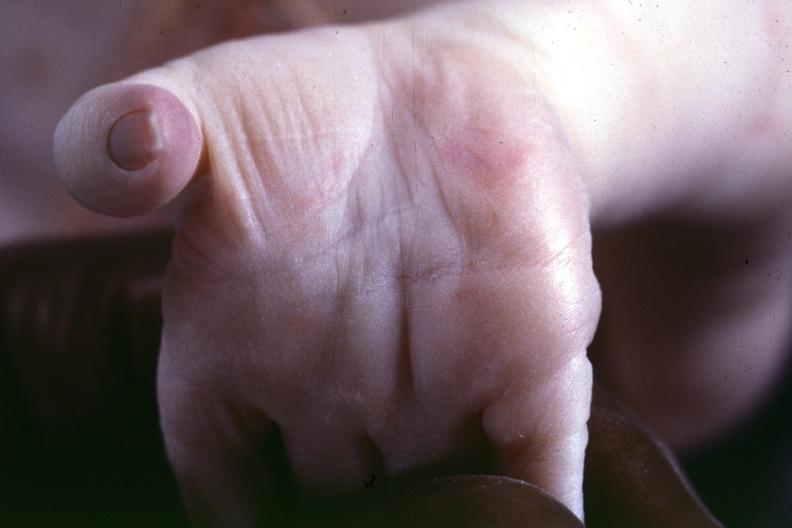s malignant lymphoma present?
Answer the question using a single word or phrase. No 